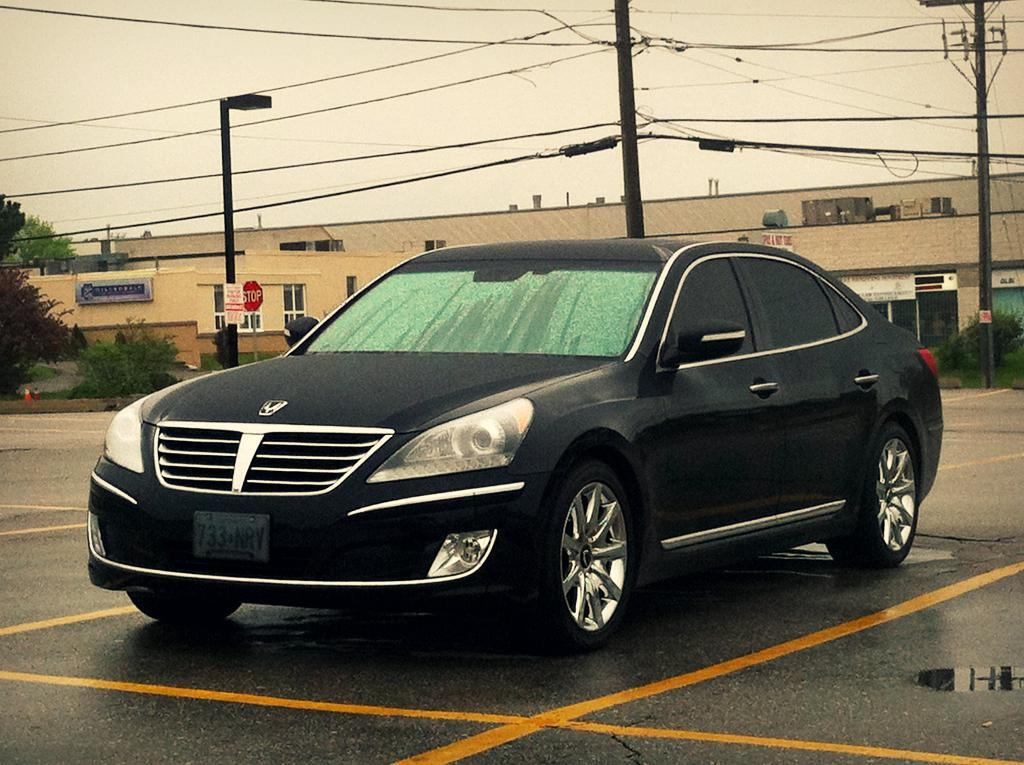What is the main subject of the image? The main subject of the image is a car. What else can be seen in the image besides the car? There are buildings, electric poles, cables, trees, and the sky visible in the image. What type of infrastructure is present in the image? Electric poles and cables are present in the image. What is the natural element visible in the image? Trees are visible in the image. What is visible in the background of the image? The sky is visible in the background of the image. What type of plantation can be seen in the image? There is no plantation present in the image. How many trains are visible in the image? There are no trains visible in the image. 